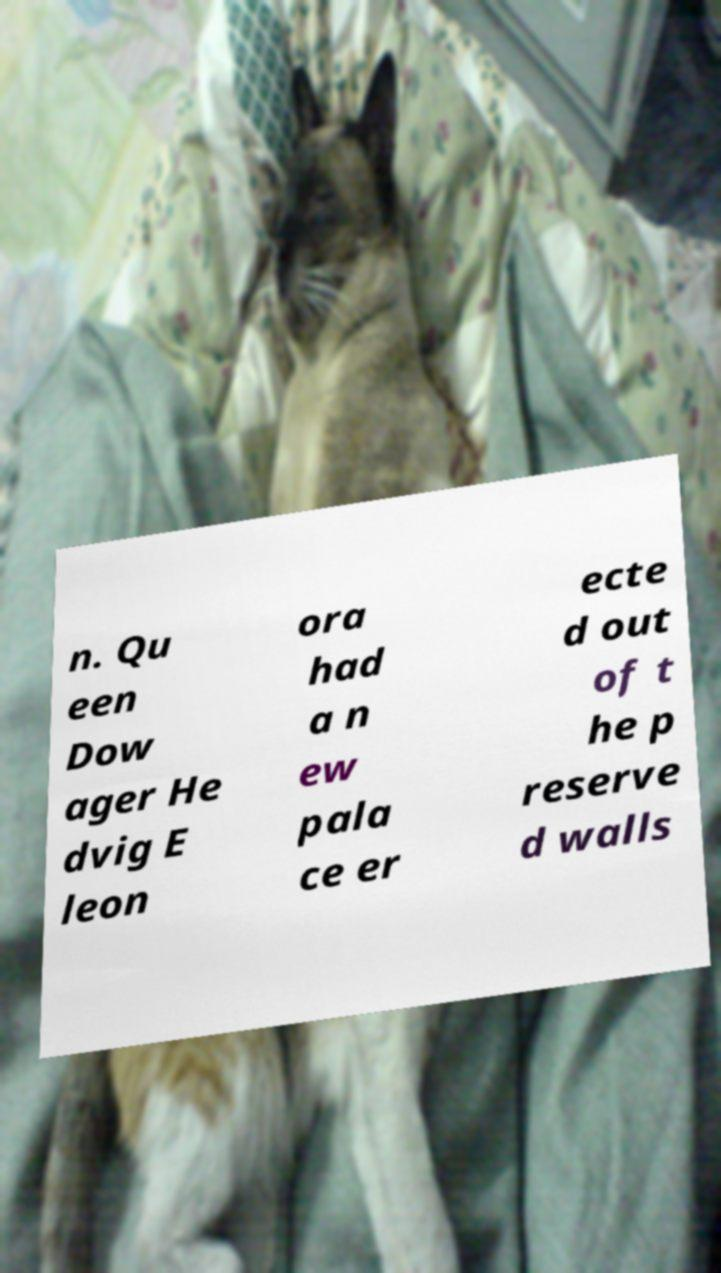Please identify and transcribe the text found in this image. n. Qu een Dow ager He dvig E leon ora had a n ew pala ce er ecte d out of t he p reserve d walls 